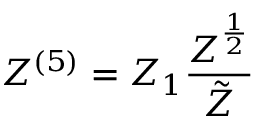Convert formula to latex. <formula><loc_0><loc_0><loc_500><loc_500>Z ^ { ( 5 ) } = Z _ { 1 } \frac { Z ^ { \frac { 1 } { 2 } } } { \tilde { Z } }</formula> 